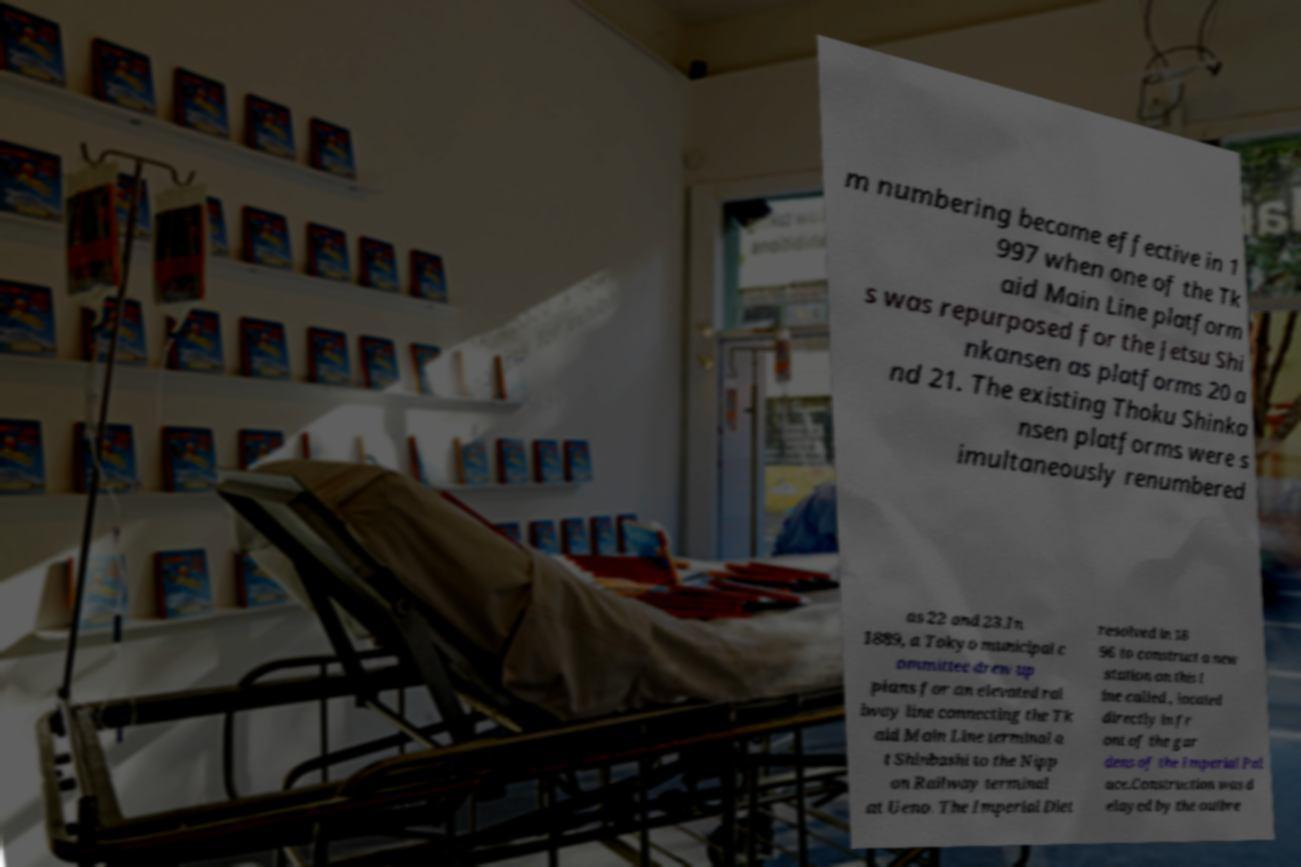Can you accurately transcribe the text from the provided image for me? m numbering became effective in 1 997 when one of the Tk aid Main Line platform s was repurposed for the Jetsu Shi nkansen as platforms 20 a nd 21. The existing Thoku Shinka nsen platforms were s imultaneously renumbered as 22 and 23.In 1889, a Tokyo municipal c ommittee drew up plans for an elevated rai lway line connecting the Tk aid Main Line terminal a t Shinbashi to the Nipp on Railway terminal at Ueno. The Imperial Diet resolved in 18 96 to construct a new station on this l ine called , located directly in fr ont of the gar dens of the Imperial Pal ace.Construction was d elayed by the outbre 